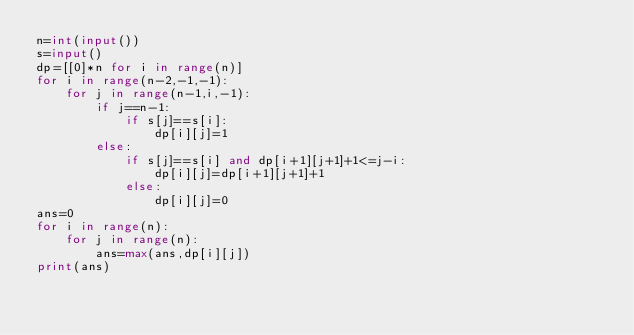<code> <loc_0><loc_0><loc_500><loc_500><_Python_>n=int(input())
s=input()
dp=[[0]*n for i in range(n)]
for i in range(n-2,-1,-1):
    for j in range(n-1,i,-1):
        if j==n-1:
            if s[j]==s[i]:
                dp[i][j]=1
        else:
            if s[j]==s[i] and dp[i+1][j+1]+1<=j-i:
                dp[i][j]=dp[i+1][j+1]+1
            else:
                dp[i][j]=0
ans=0
for i in range(n):
    for j in range(n):
        ans=max(ans,dp[i][j])
print(ans)</code> 